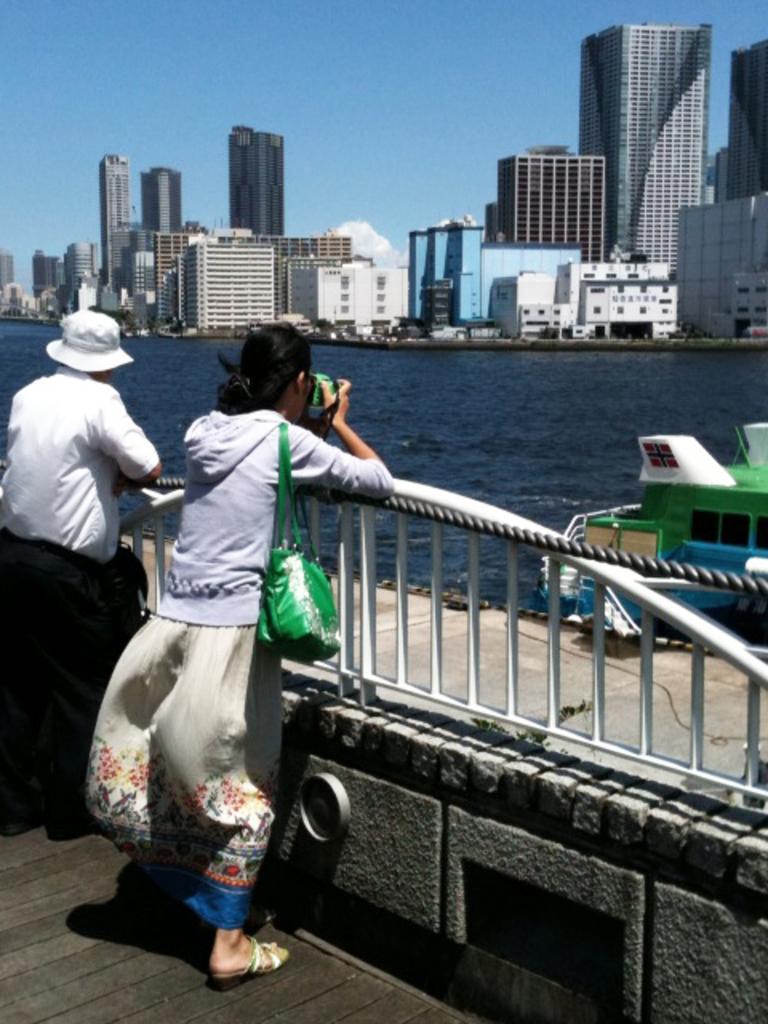Please provide a concise description of this image. I can see the man and woman standing. This woman is holding a camera in her hands and clicking pictures. This looks like a boat. I think this is the river with the water flowing. These are the buildings and skyscrapers. 